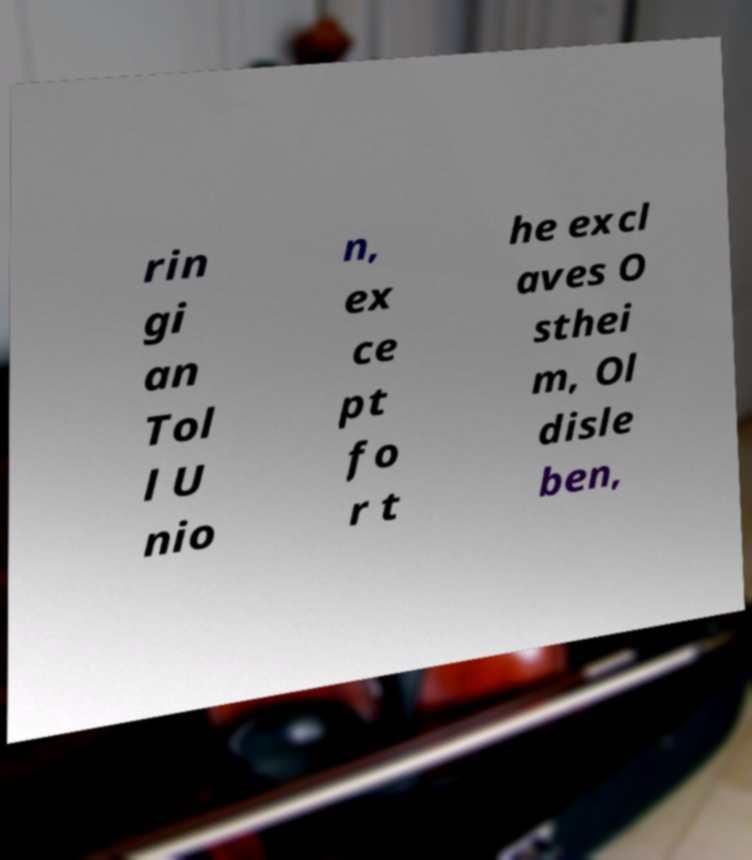I need the written content from this picture converted into text. Can you do that? rin gi an Tol l U nio n, ex ce pt fo r t he excl aves O sthei m, Ol disle ben, 